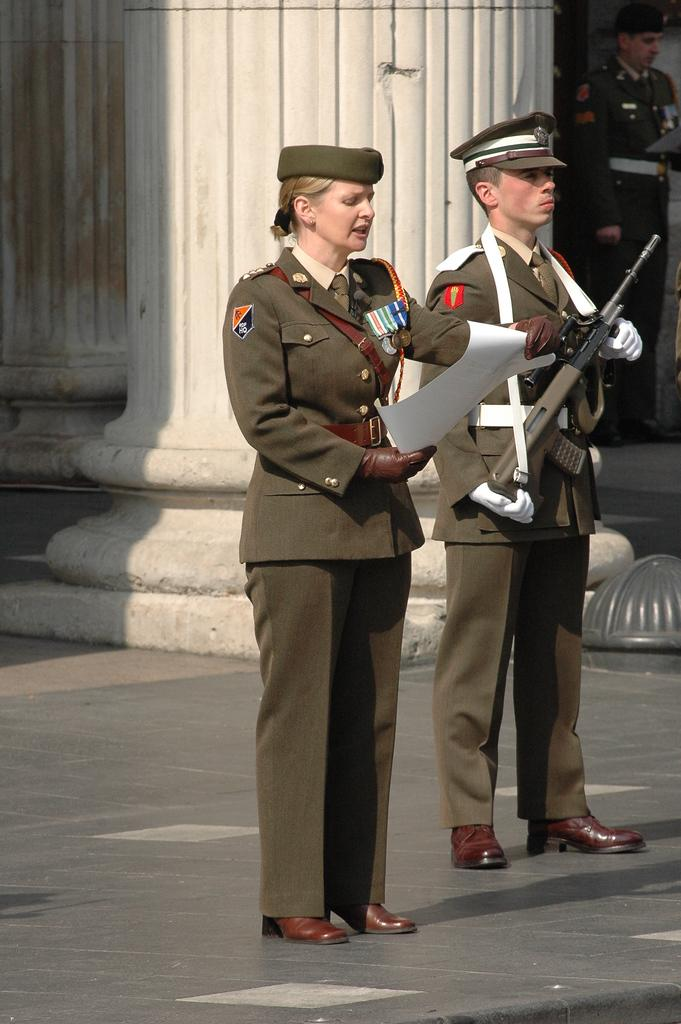How many people are present in the image? There are two people in the image. What is the woman holding in the image? The woman is holding a paper. What is the man holding in the image? The man is holding a gun in his hand. What can be seen in the background of the image? There is a building in the background of the image. What type of light can be seen coming from the gun in the image? There is no light coming from the gun in the image; it is a physical object and not a source of light. 